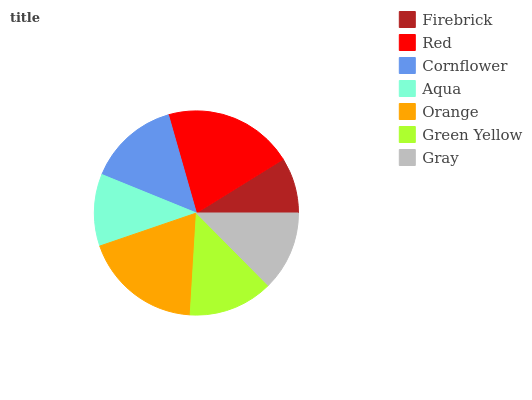Is Firebrick the minimum?
Answer yes or no. Yes. Is Red the maximum?
Answer yes or no. Yes. Is Cornflower the minimum?
Answer yes or no. No. Is Cornflower the maximum?
Answer yes or no. No. Is Red greater than Cornflower?
Answer yes or no. Yes. Is Cornflower less than Red?
Answer yes or no. Yes. Is Cornflower greater than Red?
Answer yes or no. No. Is Red less than Cornflower?
Answer yes or no. No. Is Green Yellow the high median?
Answer yes or no. Yes. Is Green Yellow the low median?
Answer yes or no. Yes. Is Orange the high median?
Answer yes or no. No. Is Orange the low median?
Answer yes or no. No. 